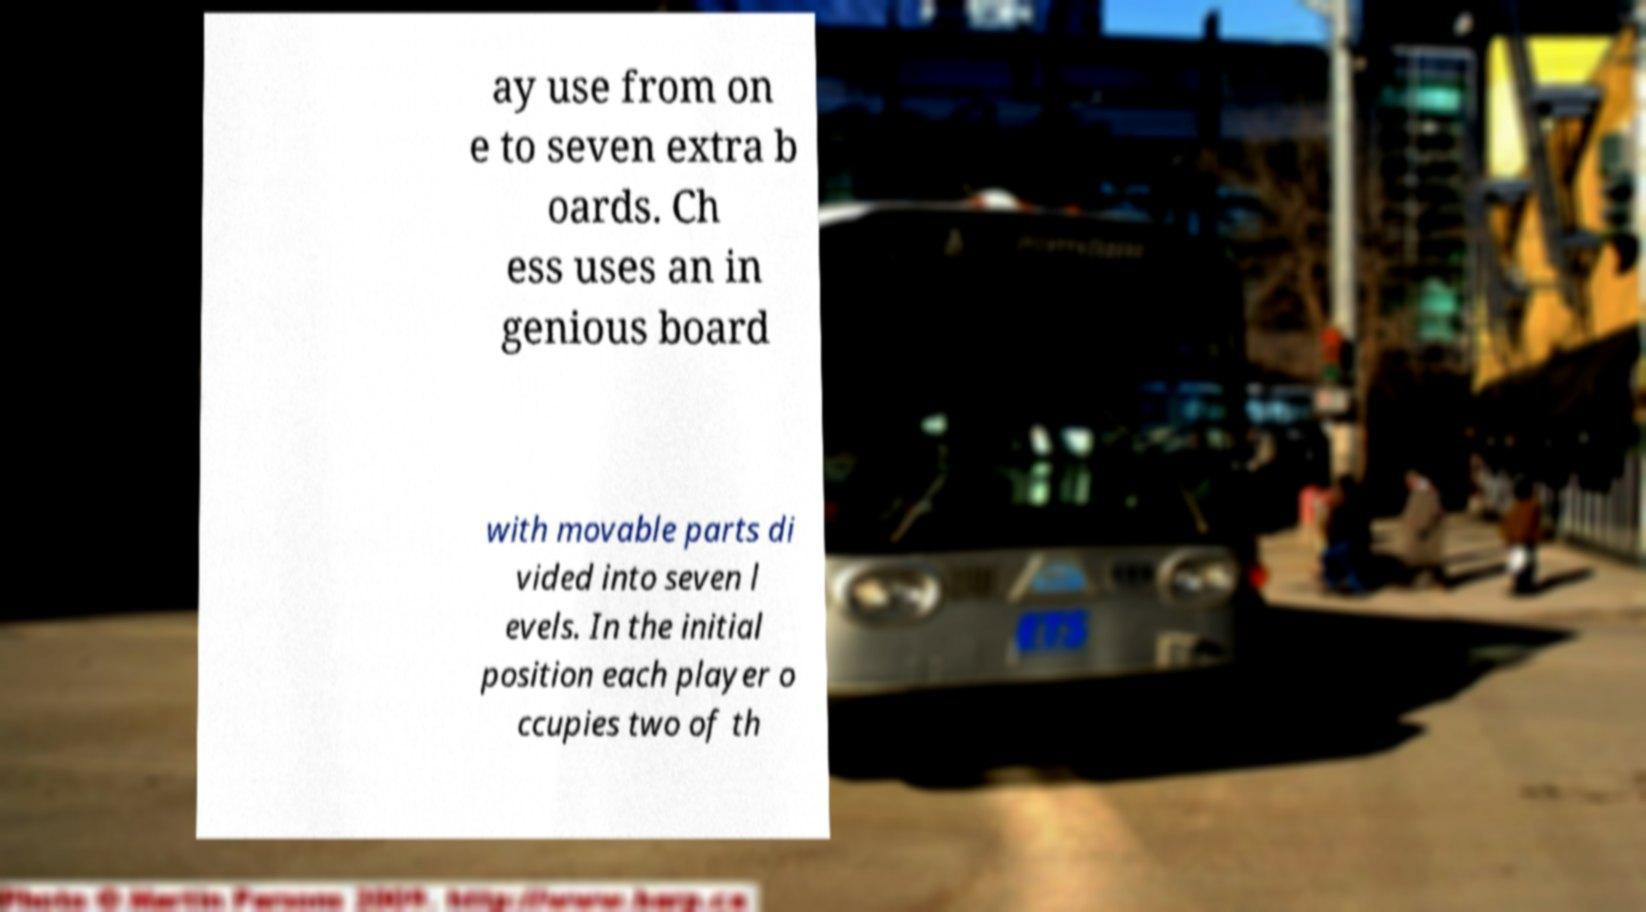For documentation purposes, I need the text within this image transcribed. Could you provide that? ay use from on e to seven extra b oards. Ch ess uses an in genious board with movable parts di vided into seven l evels. In the initial position each player o ccupies two of th 